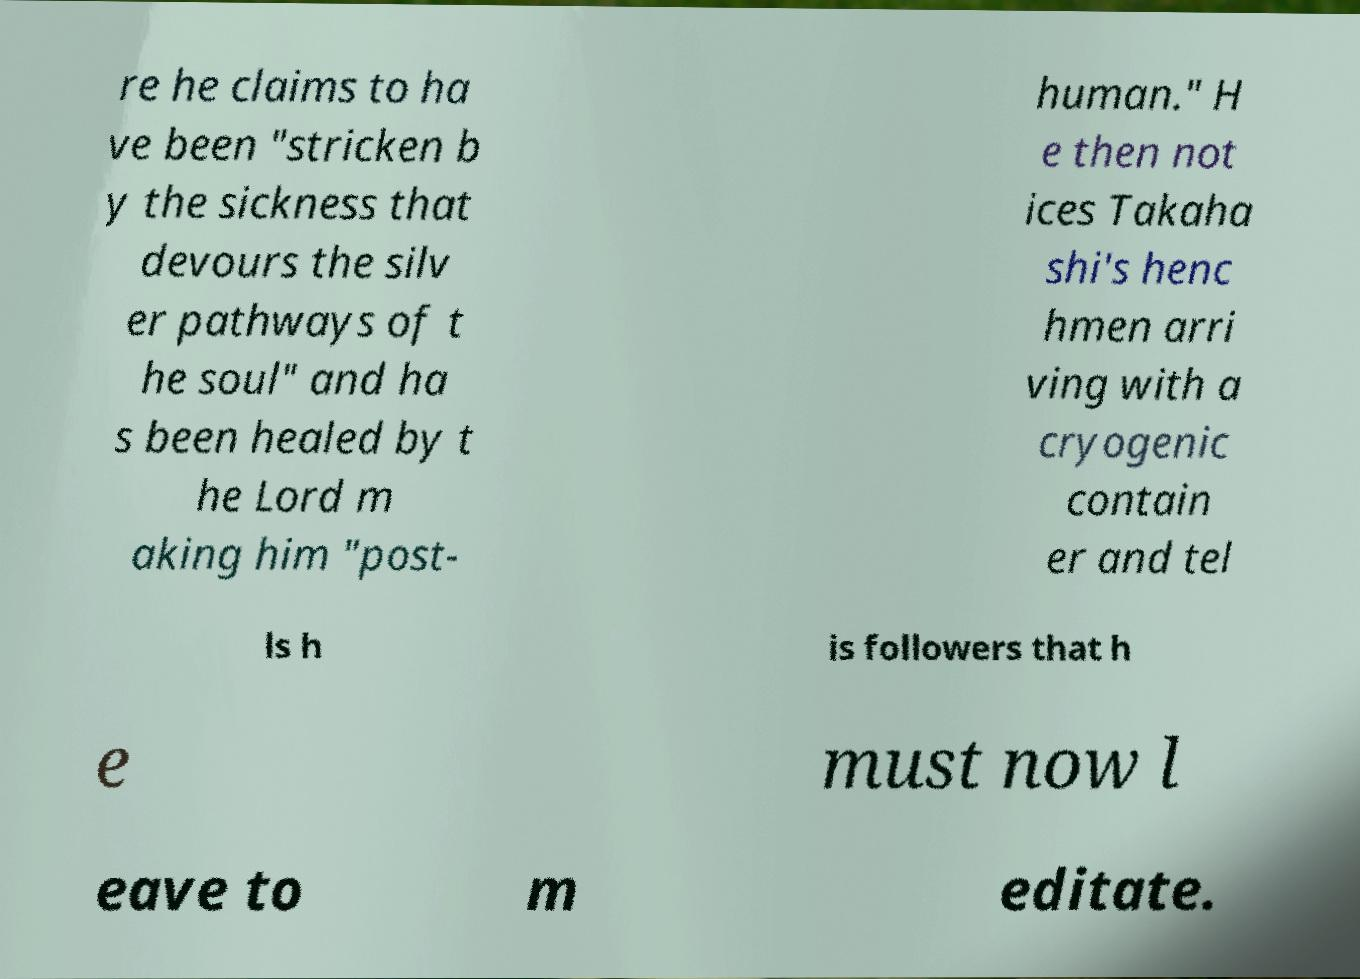Can you read and provide the text displayed in the image?This photo seems to have some interesting text. Can you extract and type it out for me? re he claims to ha ve been "stricken b y the sickness that devours the silv er pathways of t he soul" and ha s been healed by t he Lord m aking him "post- human." H e then not ices Takaha shi's henc hmen arri ving with a cryogenic contain er and tel ls h is followers that h e must now l eave to m editate. 